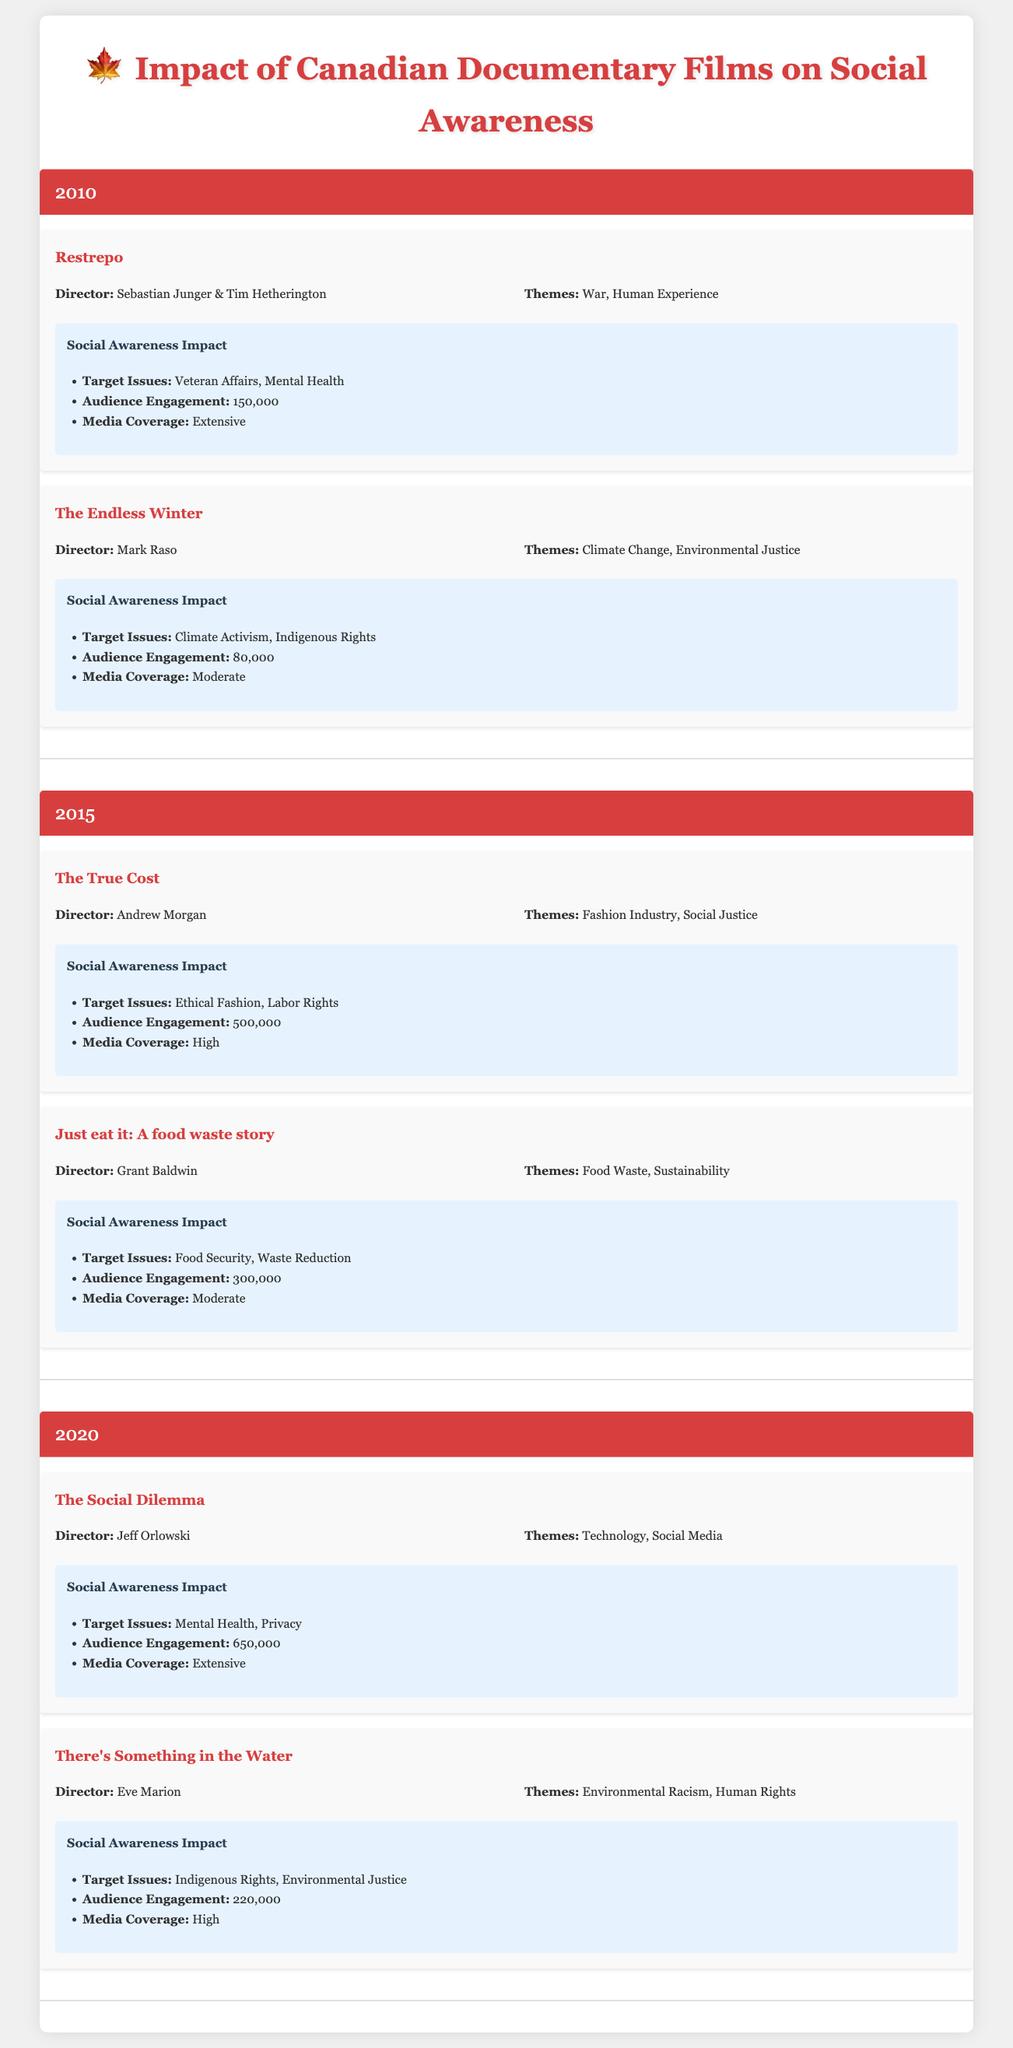What was the audience engagement for "The Social Dilemma"? Looking at the 2020 section of the table, "The Social Dilemma" has an audience engagement of 650,000.
Answer: 650,000 How many documentaries were released in total from 2010 to 2020? There are 2 documentaries listed for 2010, 2 for 2015, and 2 for 2020. Adding them up gives 2 + 2 + 2 = 6 documentaries in total.
Answer: 6 Which documentary had the highest audience engagement, and what was that engagement? The table shows that "The True Cost" released in 2015 had the highest audience engagement of 500,000 compared to others.
Answer: "The True Cost", 500,000 Did "Restrepo" have a moderate media coverage? The media coverage for "Restrepo" in the 2010 section is labeled as "Extensive," not moderate. Therefore, the statement is false.
Answer: No What is the average audience engagement of the documentaries in 2015? Looking at the audience engagement figures for 2015: "The True Cost" with 500,000 and "Just eat it: A food waste story" with 300,000. The sum is 500,000 + 300,000 = 800,000. To find the average, divide by the number of documentaries: 800,000 / 2 = 400,000.
Answer: 400,000 Which themes are explored in "There's Something in the Water"? The themes listed for "There's Something in the Water" are "Environmental Racism" and "Human Rights," according to the 2020 section of the table.
Answer: Environmental Racism, Human Rights Were any documentaries released in 2010 that focused on technology? The documentaries listed for 2010 are "Restrepo" and "The Endless Winter." Neither of these documentaries focuses on technology as a theme, so the answer is no.
Answer: No Which year had the documentary that tackled both climate change and Indigenous rights? In the 2010 section of the table, "The Endless Winter" addresses both climate change and Indigenous rights.
Answer: 2010 How many target issues were highlighted in "The Social Dilemma"? "The Social Dilemma" focuses on two target issues: "Mental Health" and "Privacy," so the count is 2 target issues.
Answer: 2 